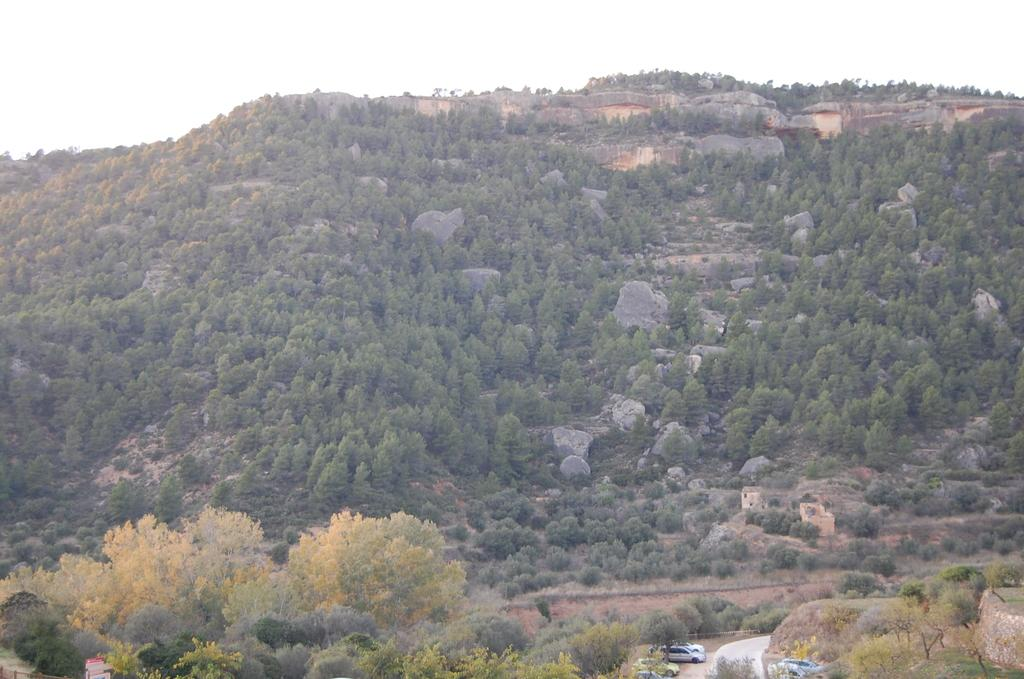What type of natural elements can be seen in the image? There are trees in the image. What other objects can be seen in the image? There are rocks and vehicles in the image. What part of the natural environment is visible in the image? The sky is visible in the image. How many patches can be seen on the tail of the animal in the image? There is no animal with a tail present in the image. What level of expertise does the beginner have in the image? There is no indication of any person's level of expertise in the image. 